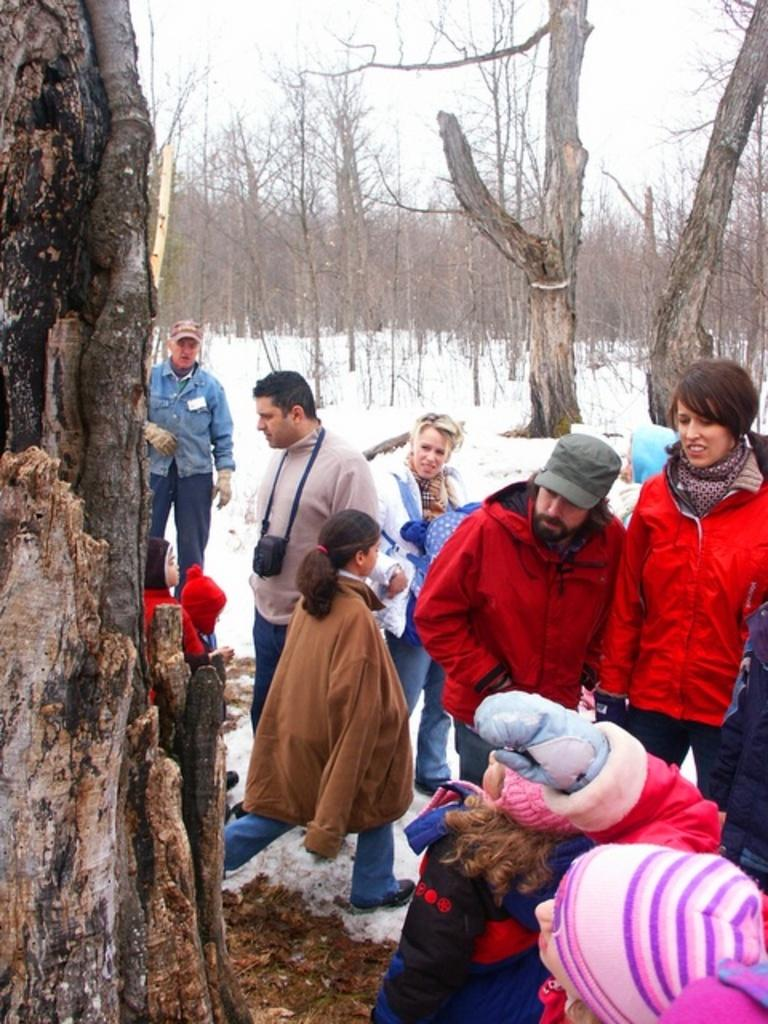What can be seen in the image? There are people standing in the image, along with trees. Can you describe the clothing of some people in the image? Some people are wearing caps in the image. How would you describe the weather in the image? The sky is cloudy, and there is snow on the ground in the image, indicating cold weather. What type of loaf is being served by the fireman in the image? There is no fireman or loaf present in the image. What is the interest rate for the loan mentioned in the image? There is no mention of a loan or interest rate in the image. 